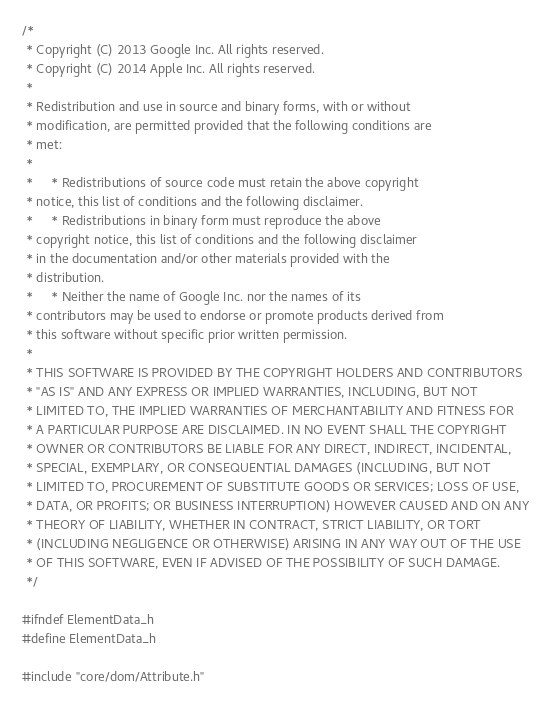Convert code to text. <code><loc_0><loc_0><loc_500><loc_500><_C_>/*
 * Copyright (C) 2013 Google Inc. All rights reserved.
 * Copyright (C) 2014 Apple Inc. All rights reserved.
 *
 * Redistribution and use in source and binary forms, with or without
 * modification, are permitted provided that the following conditions are
 * met:
 *
 *     * Redistributions of source code must retain the above copyright
 * notice, this list of conditions and the following disclaimer.
 *     * Redistributions in binary form must reproduce the above
 * copyright notice, this list of conditions and the following disclaimer
 * in the documentation and/or other materials provided with the
 * distribution.
 *     * Neither the name of Google Inc. nor the names of its
 * contributors may be used to endorse or promote products derived from
 * this software without specific prior written permission.
 *
 * THIS SOFTWARE IS PROVIDED BY THE COPYRIGHT HOLDERS AND CONTRIBUTORS
 * "AS IS" AND ANY EXPRESS OR IMPLIED WARRANTIES, INCLUDING, BUT NOT
 * LIMITED TO, THE IMPLIED WARRANTIES OF MERCHANTABILITY AND FITNESS FOR
 * A PARTICULAR PURPOSE ARE DISCLAIMED. IN NO EVENT SHALL THE COPYRIGHT
 * OWNER OR CONTRIBUTORS BE LIABLE FOR ANY DIRECT, INDIRECT, INCIDENTAL,
 * SPECIAL, EXEMPLARY, OR CONSEQUENTIAL DAMAGES (INCLUDING, BUT NOT
 * LIMITED TO, PROCUREMENT OF SUBSTITUTE GOODS OR SERVICES; LOSS OF USE,
 * DATA, OR PROFITS; OR BUSINESS INTERRUPTION) HOWEVER CAUSED AND ON ANY
 * THEORY OF LIABILITY, WHETHER IN CONTRACT, STRICT LIABILITY, OR TORT
 * (INCLUDING NEGLIGENCE OR OTHERWISE) ARISING IN ANY WAY OUT OF THE USE
 * OF THIS SOFTWARE, EVEN IF ADVISED OF THE POSSIBILITY OF SUCH DAMAGE.
 */

#ifndef ElementData_h
#define ElementData_h

#include "core/dom/Attribute.h"</code> 